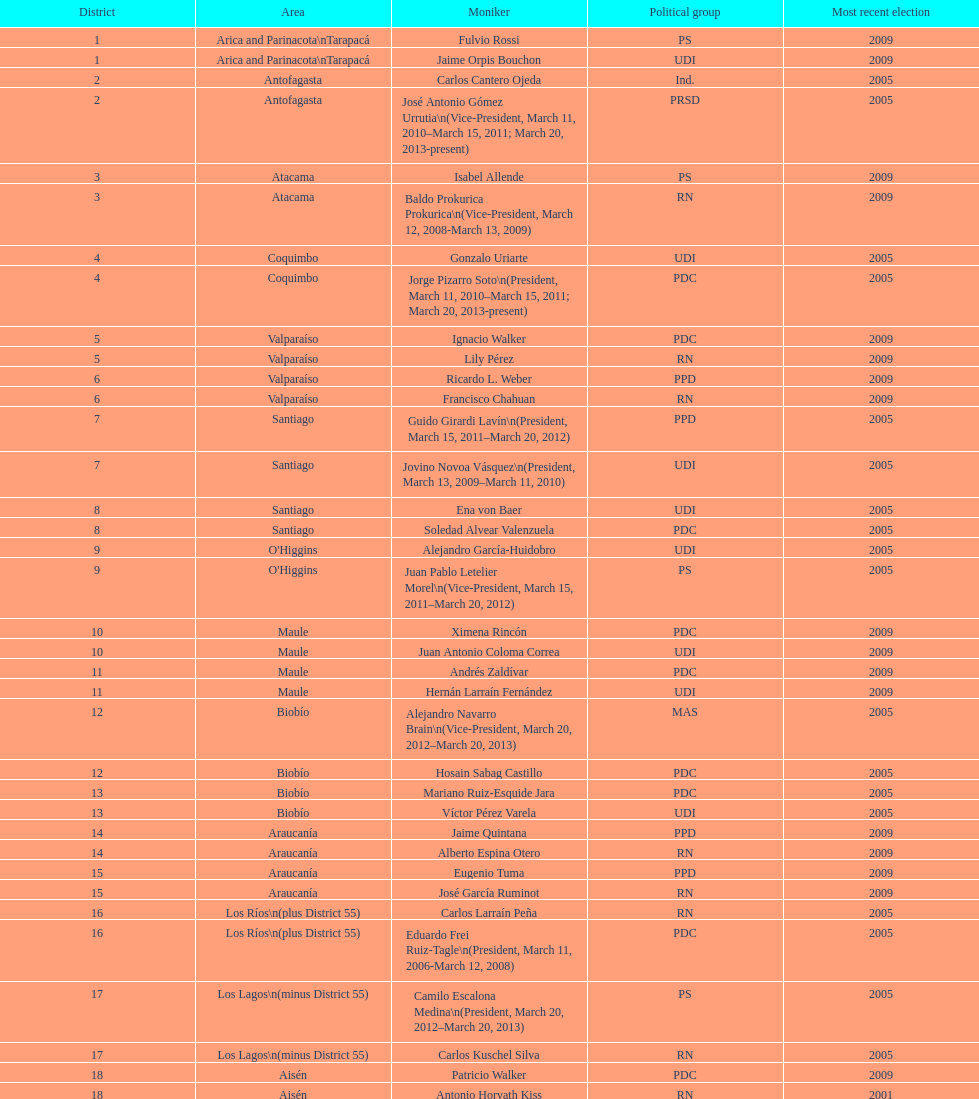When was antonio horvath kiss last elected? 2001. 